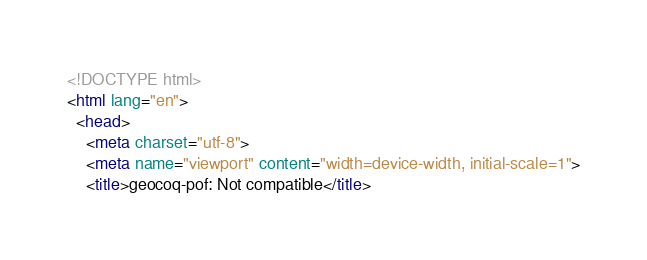Convert code to text. <code><loc_0><loc_0><loc_500><loc_500><_HTML_><!DOCTYPE html>
<html lang="en">
  <head>
    <meta charset="utf-8">
    <meta name="viewport" content="width=device-width, initial-scale=1">
    <title>geocoq-pof: Not compatible</title></code> 